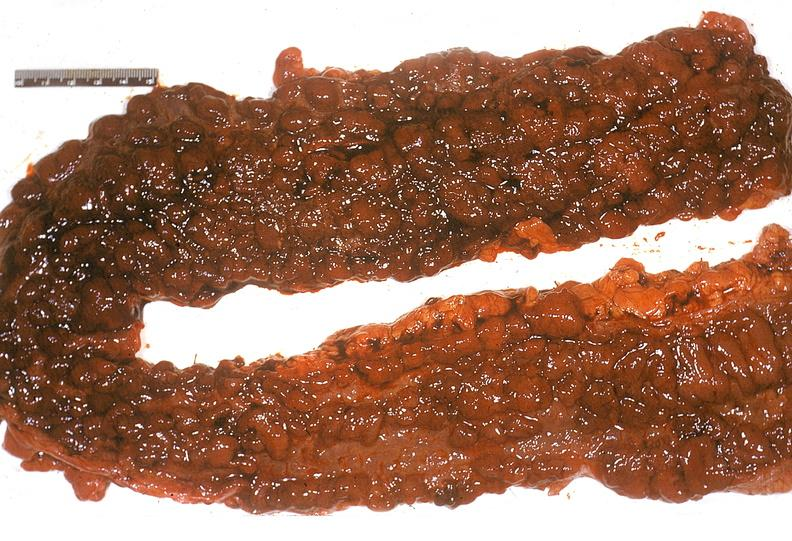s vessel present?
Answer the question using a single word or phrase. No 